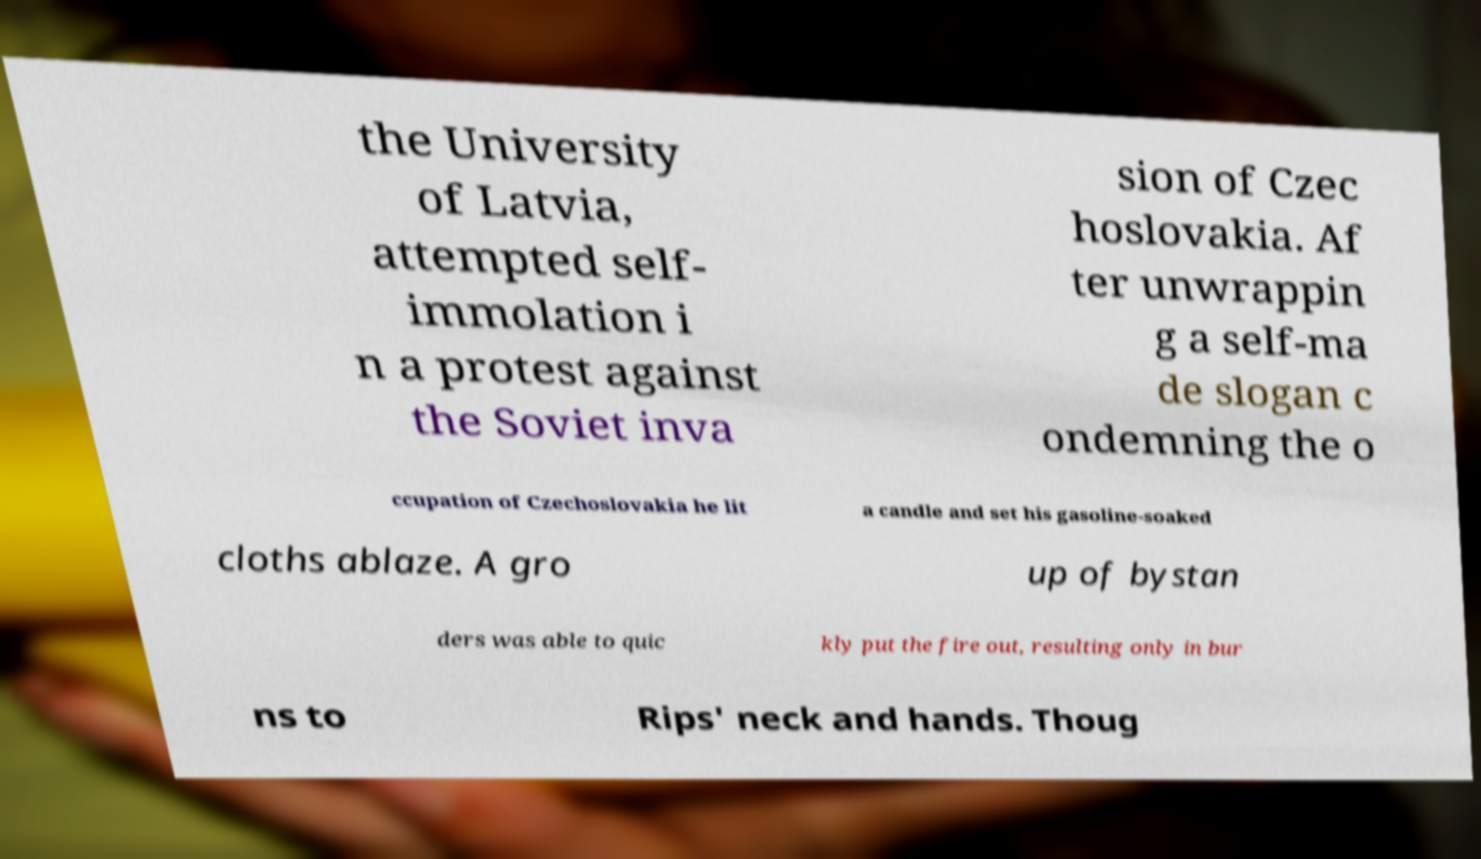Can you read and provide the text displayed in the image?This photo seems to have some interesting text. Can you extract and type it out for me? the University of Latvia, attempted self- immolation i n a protest against the Soviet inva sion of Czec hoslovakia. Af ter unwrappin g a self-ma de slogan c ondemning the o ccupation of Czechoslovakia he lit a candle and set his gasoline-soaked cloths ablaze. A gro up of bystan ders was able to quic kly put the fire out, resulting only in bur ns to Rips' neck and hands. Thoug 